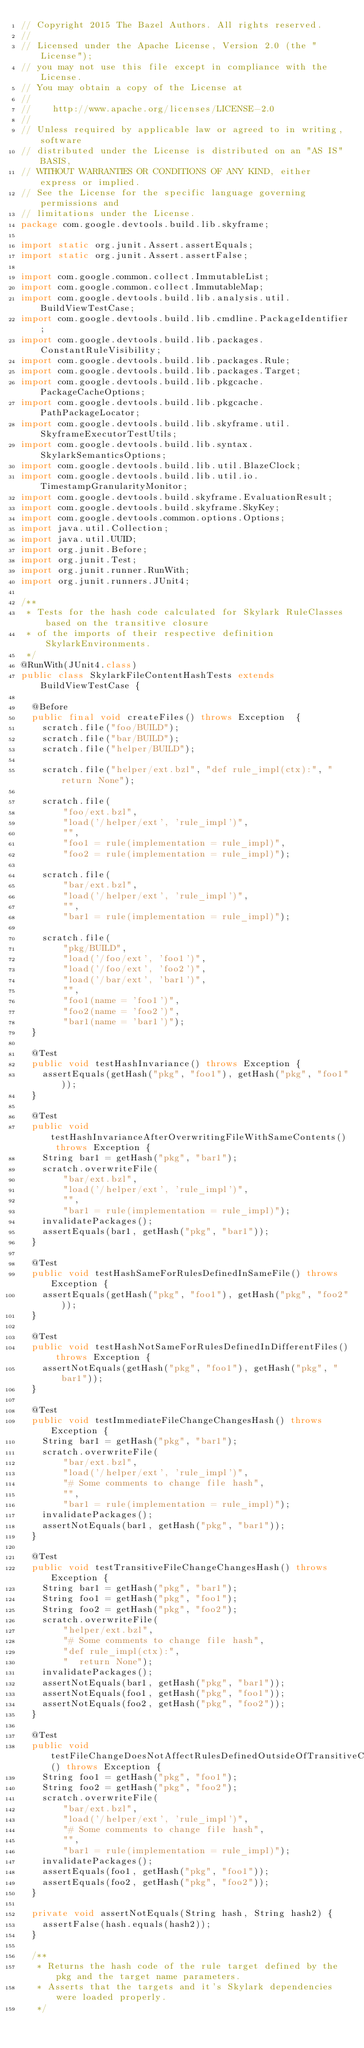Convert code to text. <code><loc_0><loc_0><loc_500><loc_500><_Java_>// Copyright 2015 The Bazel Authors. All rights reserved.
//
// Licensed under the Apache License, Version 2.0 (the "License");
// you may not use this file except in compliance with the License.
// You may obtain a copy of the License at
//
//    http://www.apache.org/licenses/LICENSE-2.0
//
// Unless required by applicable law or agreed to in writing, software
// distributed under the License is distributed on an "AS IS" BASIS,
// WITHOUT WARRANTIES OR CONDITIONS OF ANY KIND, either express or implied.
// See the License for the specific language governing permissions and
// limitations under the License.
package com.google.devtools.build.lib.skyframe;

import static org.junit.Assert.assertEquals;
import static org.junit.Assert.assertFalse;

import com.google.common.collect.ImmutableList;
import com.google.common.collect.ImmutableMap;
import com.google.devtools.build.lib.analysis.util.BuildViewTestCase;
import com.google.devtools.build.lib.cmdline.PackageIdentifier;
import com.google.devtools.build.lib.packages.ConstantRuleVisibility;
import com.google.devtools.build.lib.packages.Rule;
import com.google.devtools.build.lib.packages.Target;
import com.google.devtools.build.lib.pkgcache.PackageCacheOptions;
import com.google.devtools.build.lib.pkgcache.PathPackageLocator;
import com.google.devtools.build.lib.skyframe.util.SkyframeExecutorTestUtils;
import com.google.devtools.build.lib.syntax.SkylarkSemanticsOptions;
import com.google.devtools.build.lib.util.BlazeClock;
import com.google.devtools.build.lib.util.io.TimestampGranularityMonitor;
import com.google.devtools.build.skyframe.EvaluationResult;
import com.google.devtools.build.skyframe.SkyKey;
import com.google.devtools.common.options.Options;
import java.util.Collection;
import java.util.UUID;
import org.junit.Before;
import org.junit.Test;
import org.junit.runner.RunWith;
import org.junit.runners.JUnit4;

/**
 * Tests for the hash code calculated for Skylark RuleClasses based on the transitive closure
 * of the imports of their respective definition SkylarkEnvironments.
 */
@RunWith(JUnit4.class)
public class SkylarkFileContentHashTests extends BuildViewTestCase {

  @Before
  public final void createFiles() throws Exception  {
    scratch.file("foo/BUILD");
    scratch.file("bar/BUILD");
    scratch.file("helper/BUILD");

    scratch.file("helper/ext.bzl", "def rule_impl(ctx):", "  return None");

    scratch.file(
        "foo/ext.bzl",
        "load('/helper/ext', 'rule_impl')",
        "",
        "foo1 = rule(implementation = rule_impl)",
        "foo2 = rule(implementation = rule_impl)");

    scratch.file(
        "bar/ext.bzl",
        "load('/helper/ext', 'rule_impl')",
        "",
        "bar1 = rule(implementation = rule_impl)");

    scratch.file(
        "pkg/BUILD",
        "load('/foo/ext', 'foo1')",
        "load('/foo/ext', 'foo2')",
        "load('/bar/ext', 'bar1')",
        "",
        "foo1(name = 'foo1')",
        "foo2(name = 'foo2')",
        "bar1(name = 'bar1')");
  }

  @Test
  public void testHashInvariance() throws Exception {
    assertEquals(getHash("pkg", "foo1"), getHash("pkg", "foo1"));
  }

  @Test
  public void testHashInvarianceAfterOverwritingFileWithSameContents() throws Exception {
    String bar1 = getHash("pkg", "bar1");
    scratch.overwriteFile(
        "bar/ext.bzl",
        "load('/helper/ext', 'rule_impl')",
        "",
        "bar1 = rule(implementation = rule_impl)");
    invalidatePackages();
    assertEquals(bar1, getHash("pkg", "bar1"));
  }

  @Test
  public void testHashSameForRulesDefinedInSameFile() throws Exception {
    assertEquals(getHash("pkg", "foo1"), getHash("pkg", "foo2"));
  }

  @Test
  public void testHashNotSameForRulesDefinedInDifferentFiles() throws Exception {
    assertNotEquals(getHash("pkg", "foo1"), getHash("pkg", "bar1"));
  }

  @Test
  public void testImmediateFileChangeChangesHash() throws Exception {
    String bar1 = getHash("pkg", "bar1");
    scratch.overwriteFile(
        "bar/ext.bzl",
        "load('/helper/ext', 'rule_impl')",
        "# Some comments to change file hash",
        "",
        "bar1 = rule(implementation = rule_impl)");
    invalidatePackages();
    assertNotEquals(bar1, getHash("pkg", "bar1"));
  }

  @Test
  public void testTransitiveFileChangeChangesHash() throws Exception {
    String bar1 = getHash("pkg", "bar1");
    String foo1 = getHash("pkg", "foo1");
    String foo2 = getHash("pkg", "foo2");
    scratch.overwriteFile(
        "helper/ext.bzl",
        "# Some comments to change file hash",
        "def rule_impl(ctx):",
        "  return None");
    invalidatePackages();
    assertNotEquals(bar1, getHash("pkg", "bar1"));
    assertNotEquals(foo1, getHash("pkg", "foo1"));
    assertNotEquals(foo2, getHash("pkg", "foo2"));
  }

  @Test
  public void testFileChangeDoesNotAffectRulesDefinedOutsideOfTransitiveClosure() throws Exception {
    String foo1 = getHash("pkg", "foo1");
    String foo2 = getHash("pkg", "foo2");
    scratch.overwriteFile(
        "bar/ext.bzl",
        "load('/helper/ext', 'rule_impl')",
        "# Some comments to change file hash",
        "",
        "bar1 = rule(implementation = rule_impl)");
    invalidatePackages();
    assertEquals(foo1, getHash("pkg", "foo1"));
    assertEquals(foo2, getHash("pkg", "foo2"));
  }

  private void assertNotEquals(String hash, String hash2) {
    assertFalse(hash.equals(hash2));
  }

  /**
   * Returns the hash code of the rule target defined by the pkg and the target name parameters.
   * Asserts that the targets and it's Skylark dependencies were loaded properly.
   */</code> 